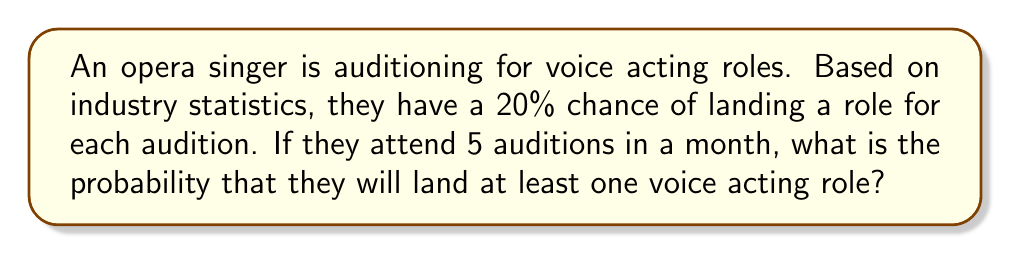Teach me how to tackle this problem. Let's approach this step-by-step:

1) First, let's define our events:
   - Success (S): Landing at least one role
   - Failure (F): Not landing any role

2) It's easier to calculate the probability of failure and then subtract from 1 to get the probability of success.

3) The probability of not landing a role in a single audition is:
   $1 - 0.20 = 0.80$ or $80\%$

4) For all 5 auditions to be unsuccessful, we need to fail 5 times in a row. The probability of this is:
   $$(0.80)^5 = 0.32768$$

5) Therefore, the probability of landing at least one role is:
   $$1 - (0.80)^5 = 1 - 0.32768 = 0.67232$$

6) We can express this as a percentage:
   $$0.67232 \times 100\% = 67.232\%$$

This problem utilizes the concept of complementary events and independent probability. The opera singer has a 67.232% chance of landing at least one voice acting role out of 5 auditions.
Answer: $67.232\%$ 